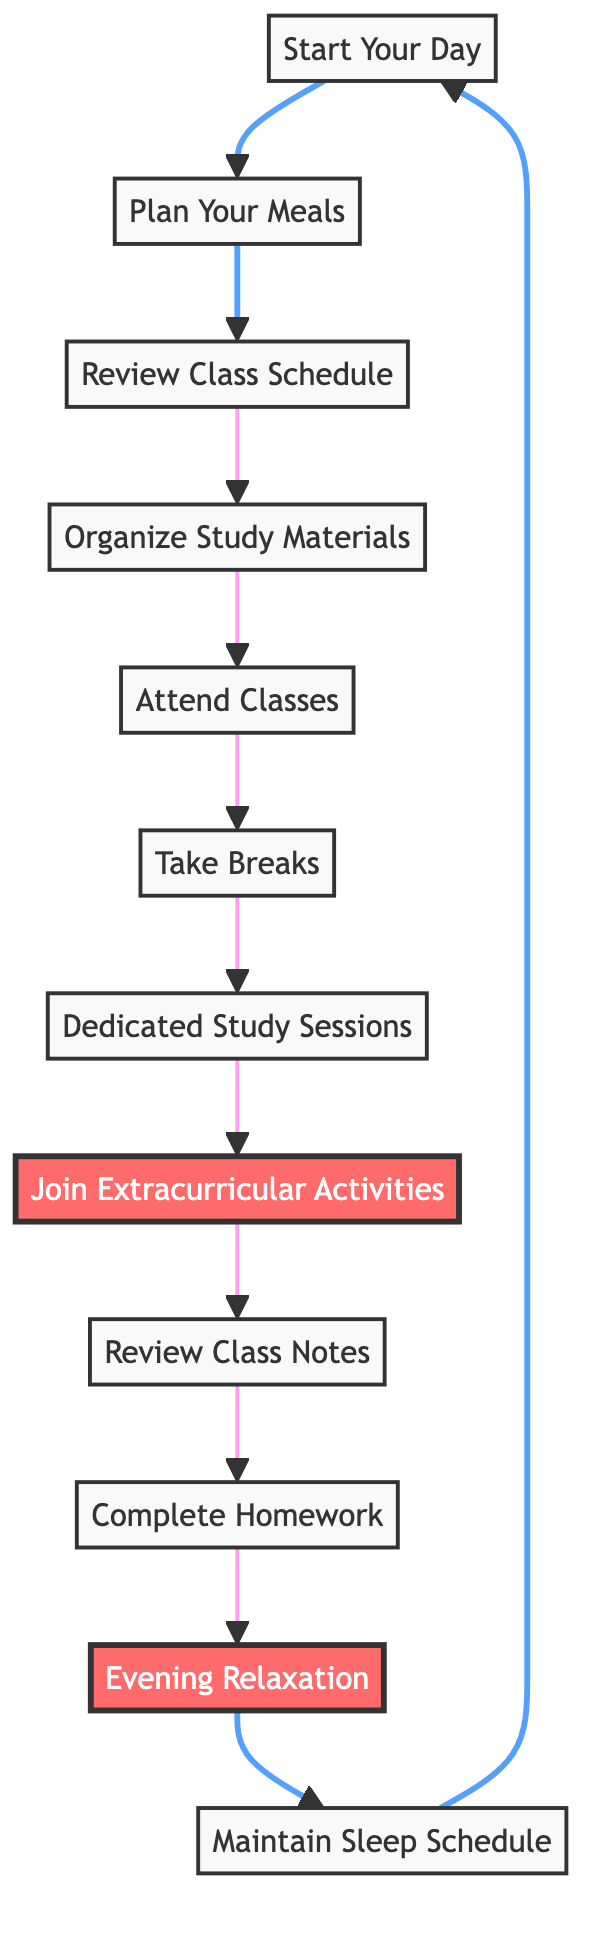What is the first step in the flowchart? The first step in the flowchart is labeled as "Start Your Day," indicating the start of the daily schedule process.
Answer: Start Your Day How many overall steps are there in this daily schedule management process? By counting the individual steps outlined in the flowchart, there are a total of 12 steps from "Start Your Day" to "Maintain Sleep Schedule."
Answer: 12 What is the last activity before winding down for the evening? According to the flowchart, the last activity before the evening routine is "Complete Homework," which is followed by "Evening Relaxation."
Answer: Complete Homework Which activity comes right after reviewing class notes? "Complete Homework" follows "Review Class Notes" as indicated in the flowchart, representing the transition from reviewing notes to working on assignments.
Answer: Complete Homework What are some examples of activities mentioned in the extracurricular activities node? The "Join Extracurricular Activities" node includes options like clubs, sports (like the Red Storm), or other campus events, suggesting engagement beyond academics.
Answer: clubs, sports, campus events Explain the relationship between meal planning and class scheduling. "Plan Your Meals" is a prerequisite before moving on to "Review Class Schedule," indicating that planning meals occurs before reviewing the day's academic timetable.
Answer: Plan Your Meals before Review Class Schedule What is the purpose of the "Take Breaks" step? The "Take Breaks" step emphasizes the importance of scheduling short breaks between study sessions to prevent burnout, promoting better productivity.
Answer: Avoid burnout Describe the final routine of the daily schedule management flowchart. The flowchart concludes with "Maintain Sleep Schedule," reiterating the significance of getting sufficient sleep to prepare for the following day’s activities.
Answer: Maintain Sleep Schedule Which node highlights the importance of relaxation? The "Evening Relaxation" node highlights the importance of engaging in relaxing activities, like watching a Red Storm game, to help unwind after a busy day.
Answer: Evening Relaxation What is the direction of flow in this diagram? The flow of the diagram moves from bottom to top, illustrating the sequence of daily management activities starting with morning routines and concluding with evening routines.
Answer: Bottom to up 